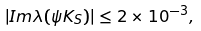<formula> <loc_0><loc_0><loc_500><loc_500>| I m \lambda ( \psi K _ { S } ) | \leq 2 \times 1 0 ^ { - 3 } ,</formula> 